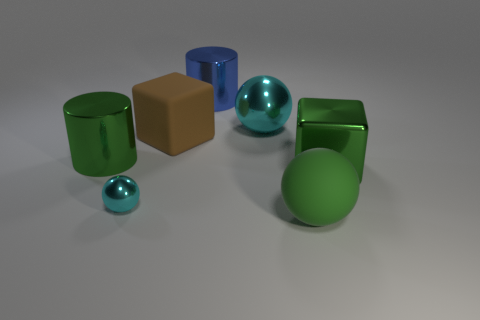Could you describe the overall color scheme of the arrangement? Certainly, the objects in the image present a color scheme that includes shades of green, blue, and brown, with the glossy finishes on several items enhancing their vibrant tones. 